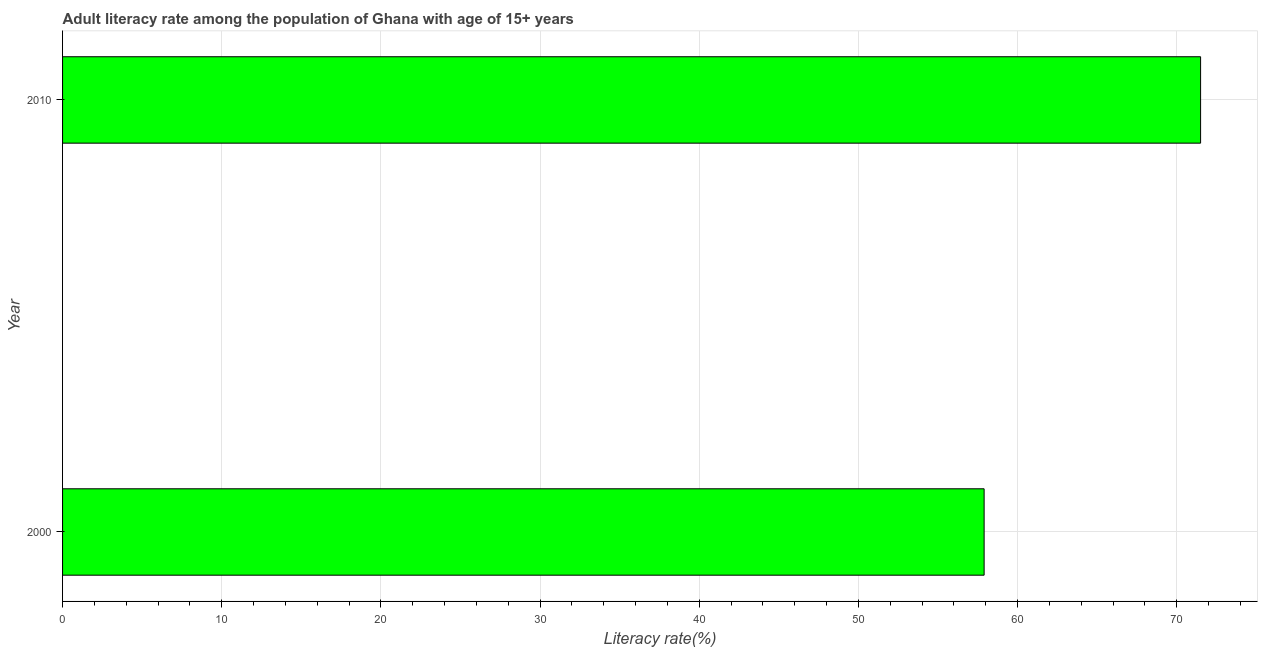Does the graph contain grids?
Make the answer very short. Yes. What is the title of the graph?
Ensure brevity in your answer.  Adult literacy rate among the population of Ghana with age of 15+ years. What is the label or title of the X-axis?
Provide a succinct answer. Literacy rate(%). What is the adult literacy rate in 2000?
Keep it short and to the point. 57.9. Across all years, what is the maximum adult literacy rate?
Offer a very short reply. 71.5. Across all years, what is the minimum adult literacy rate?
Give a very brief answer. 57.9. In which year was the adult literacy rate maximum?
Offer a terse response. 2010. In which year was the adult literacy rate minimum?
Offer a terse response. 2000. What is the sum of the adult literacy rate?
Offer a terse response. 129.39. What is the average adult literacy rate per year?
Ensure brevity in your answer.  64.7. What is the median adult literacy rate?
Your answer should be compact. 64.7. What is the ratio of the adult literacy rate in 2000 to that in 2010?
Offer a terse response. 0.81. Is the adult literacy rate in 2000 less than that in 2010?
Your answer should be very brief. Yes. What is the Literacy rate(%) in 2000?
Your response must be concise. 57.9. What is the Literacy rate(%) of 2010?
Provide a succinct answer. 71.5. What is the difference between the Literacy rate(%) in 2000 and 2010?
Make the answer very short. -13.6. What is the ratio of the Literacy rate(%) in 2000 to that in 2010?
Your response must be concise. 0.81. 